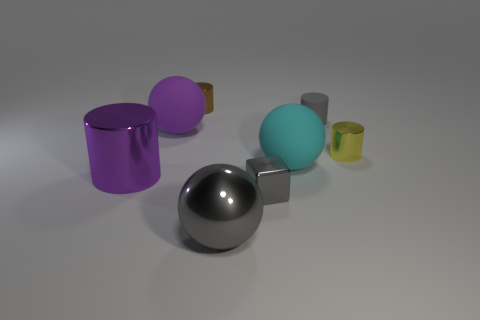There is another rubber object that is the same shape as the large cyan matte thing; what color is it?
Your answer should be compact. Purple. Do the brown thing and the large purple rubber thing have the same shape?
Make the answer very short. No. The purple shiny thing that is the same shape as the tiny gray matte thing is what size?
Your answer should be compact. Large. How many small things are the same material as the tiny yellow cylinder?
Your answer should be compact. 2. How many things are purple balls or big cylinders?
Offer a terse response. 2. There is a small gray thing that is behind the large purple metallic thing; is there a tiny metallic thing on the right side of it?
Offer a very short reply. Yes. Is the number of large spheres to the right of the brown shiny cylinder greater than the number of purple matte things left of the big cylinder?
Your answer should be compact. Yes. There is a cube that is the same color as the large metallic ball; what material is it?
Offer a terse response. Metal. How many metallic cylinders have the same color as the large shiny ball?
Your answer should be compact. 0. There is a big shiny object to the left of the brown thing; does it have the same color as the matte thing left of the shiny ball?
Your answer should be very brief. Yes. 